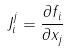<formula> <loc_0><loc_0><loc_500><loc_500>J _ { i } ^ { j } = \frac { \partial f _ { i } } { \partial x _ { j } }</formula> 